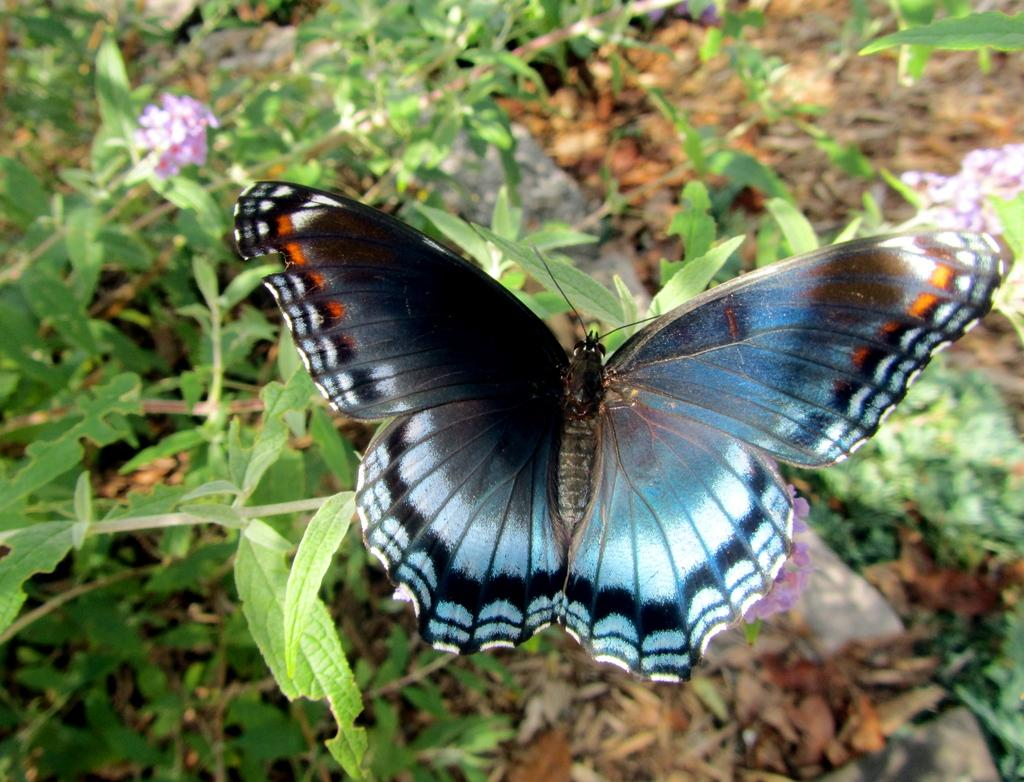What is the main subject of the image? There is a butterfly in the image. Where is the butterfly located? The butterfly is on a plant. What recommendations did the committee make to increase the number of oranges in the image? There is no committee, recommendation, or oranges present in the image; it features a butterfly on a plant. 